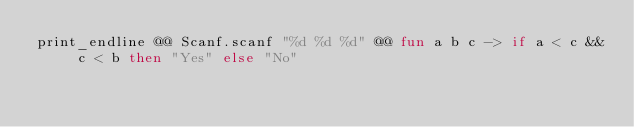Convert code to text. <code><loc_0><loc_0><loc_500><loc_500><_OCaml_>print_endline @@ Scanf.scanf "%d %d %d" @@ fun a b c -> if a < c && c < b then "Yes" else "No"</code> 